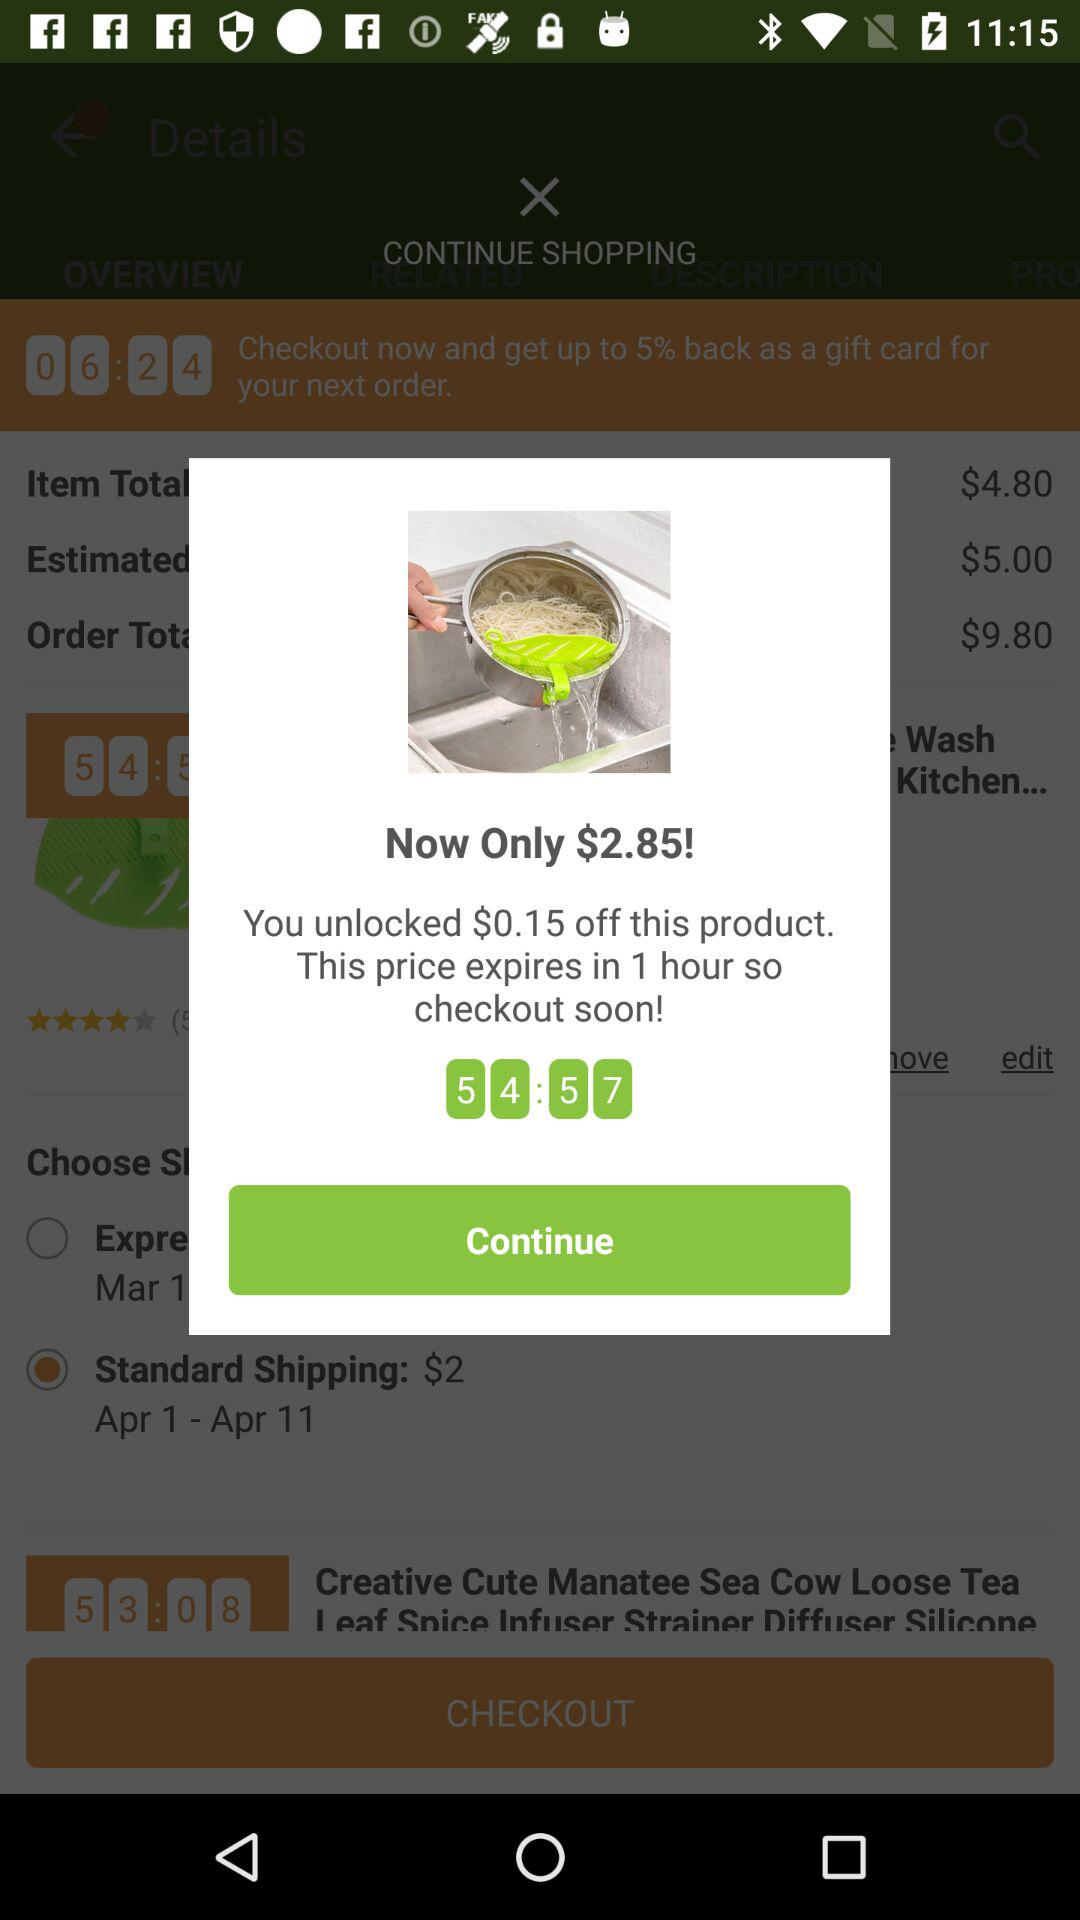When will the offer expire? The offer will expire in 1 hour. 